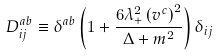Convert formula to latex. <formula><loc_0><loc_0><loc_500><loc_500>D _ { i j } ^ { a b } \equiv \delta ^ { a b } \left ( { 1 + \frac { { 6 \lambda _ { + } ^ { 2 } \left ( { v ^ { c } } \right ) ^ { 2 } } } { \Delta + m ^ { 2 } } } \right ) \delta _ { i j }</formula> 